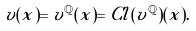<formula> <loc_0><loc_0><loc_500><loc_500>v ( x ) = v ^ { \mathbb { Q } } ( x ) = C l ( v ^ { \mathbb { Q } } ) ( x ) .</formula> 